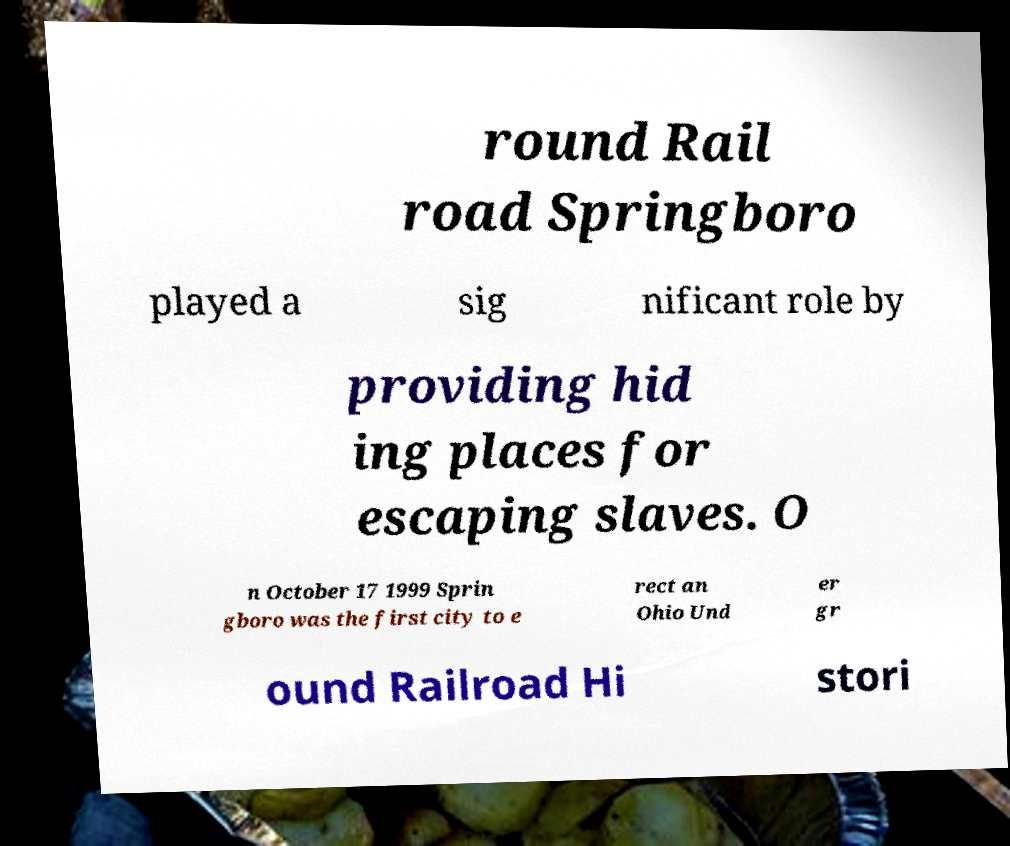Please identify and transcribe the text found in this image. round Rail road Springboro played a sig nificant role by providing hid ing places for escaping slaves. O n October 17 1999 Sprin gboro was the first city to e rect an Ohio Und er gr ound Railroad Hi stori 